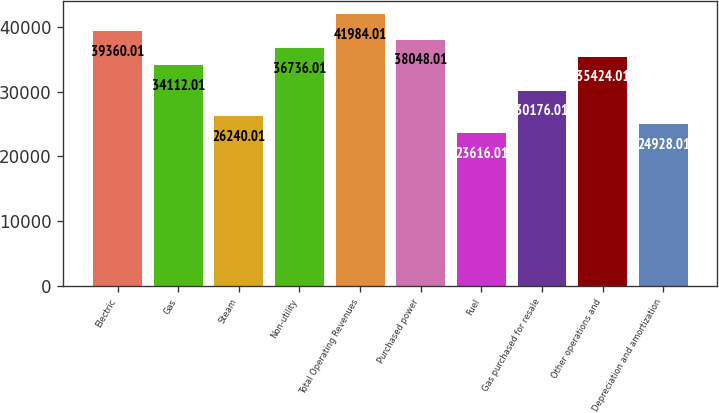Convert chart to OTSL. <chart><loc_0><loc_0><loc_500><loc_500><bar_chart><fcel>Electric<fcel>Gas<fcel>Steam<fcel>Non-utility<fcel>Total Operating Revenues<fcel>Purchased power<fcel>Fuel<fcel>Gas purchased for resale<fcel>Other operations and<fcel>Depreciation and amortization<nl><fcel>39360<fcel>34112<fcel>26240<fcel>36736<fcel>41984<fcel>38048<fcel>23616<fcel>30176<fcel>35424<fcel>24928<nl></chart> 